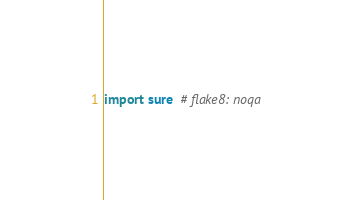Convert code to text. <code><loc_0><loc_0><loc_500><loc_500><_Python_>import sure  # flake8: noqa
</code> 